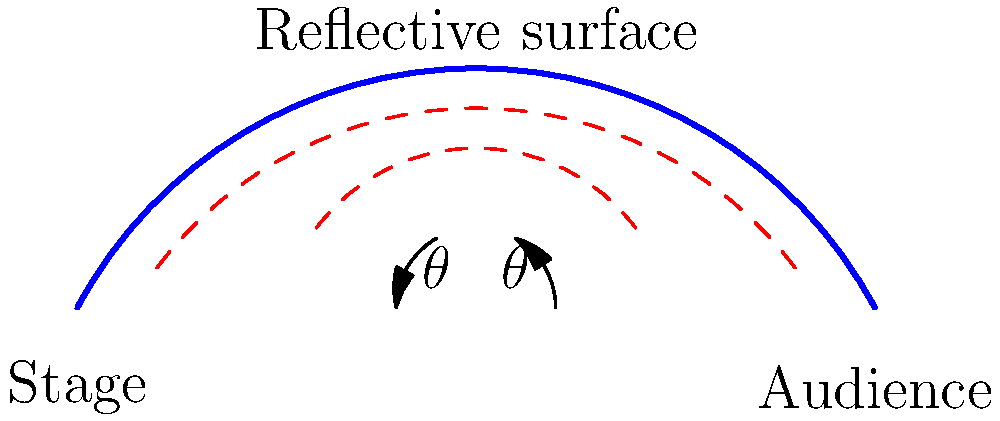In the cross-sectional diagram of an opera house's acoustic ceiling, the reflective surface is designed to redirect sound waves from the stage to the audience. If the incident angle of the sound wave is $\theta$, what should be the angle of the ceiling's tangent line at the point of reflection to ensure optimal sound distribution? To ensure optimal sound distribution in an opera house, we need to understand the principle of reflection for sound waves. This principle is similar to the reflection of light waves.

Step 1: Recall the law of reflection
The law of reflection states that the angle of incidence is equal to the angle of reflection.

Step 2: Analyze the diagram
In the diagram, we see that the sound wave approaches the ceiling at an angle $\theta$ to the normal (perpendicular) line.

Step 3: Determine the optimal reflection
For the sound to be redirected towards the audience, we want the reflected wave to also form an angle $\theta$ with the normal, but on the opposite side.

Step 4: Calculate the angle of the ceiling's tangent line
To achieve this reflection, the ceiling's surface (or its tangent line at the point of reflection) should bisect the angle between the incident and reflected waves.

Step 5: Apply geometry
The incident wave forms an angle $\theta$ with the normal, and the reflected wave should form the same angle $\theta$ on the other side of the normal. The total angle between these two directions is $2\theta$.

Step 6: Determine the optimal angle
The ceiling's tangent line should bisect this total angle. Therefore, it should form an angle of $\theta$ with respect to the horizontal.

In conclusion, for optimal sound distribution, the angle of the ceiling's tangent line at the point of reflection should be $\theta$ with respect to the horizontal, which is the same as the incident angle of the sound wave.
Answer: $\theta$ 